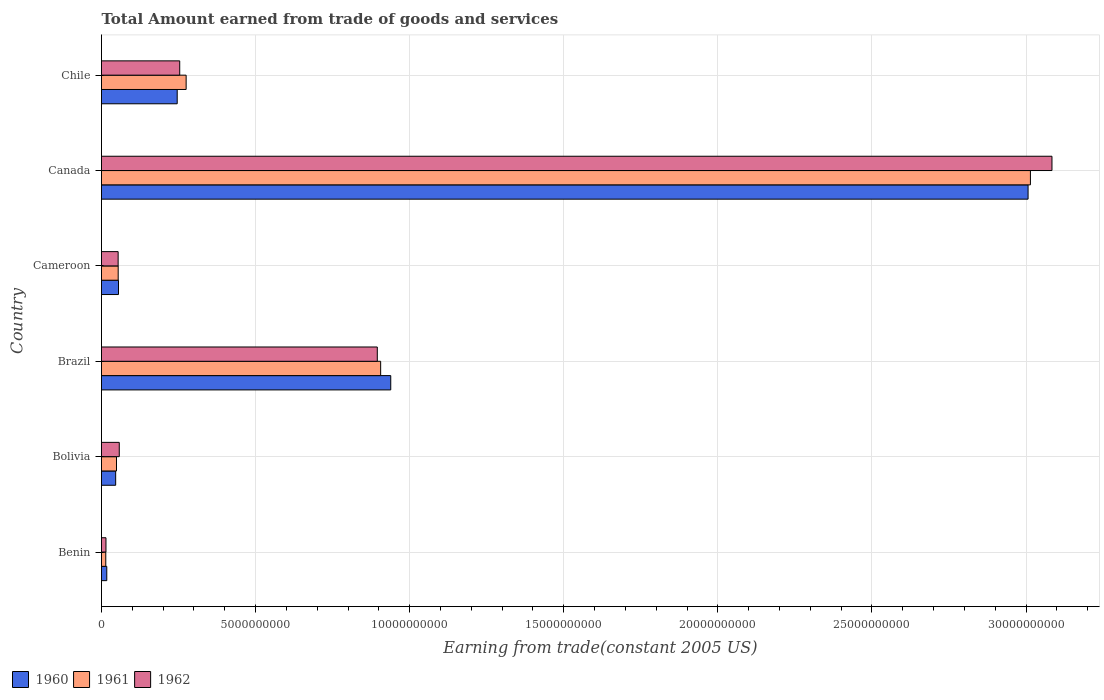How many different coloured bars are there?
Provide a short and direct response. 3. Are the number of bars per tick equal to the number of legend labels?
Your answer should be compact. Yes. How many bars are there on the 1st tick from the top?
Give a very brief answer. 3. How many bars are there on the 4th tick from the bottom?
Keep it short and to the point. 3. What is the label of the 2nd group of bars from the top?
Give a very brief answer. Canada. In how many cases, is the number of bars for a given country not equal to the number of legend labels?
Keep it short and to the point. 0. What is the total amount earned by trading goods and services in 1961 in Canada?
Provide a short and direct response. 3.01e+1. Across all countries, what is the maximum total amount earned by trading goods and services in 1962?
Provide a short and direct response. 3.08e+1. Across all countries, what is the minimum total amount earned by trading goods and services in 1960?
Make the answer very short. 1.71e+08. In which country was the total amount earned by trading goods and services in 1960 minimum?
Give a very brief answer. Benin. What is the total total amount earned by trading goods and services in 1962 in the graph?
Ensure brevity in your answer.  4.36e+1. What is the difference between the total amount earned by trading goods and services in 1960 in Cameroon and that in Canada?
Your answer should be compact. -2.95e+1. What is the difference between the total amount earned by trading goods and services in 1961 in Bolivia and the total amount earned by trading goods and services in 1962 in Brazil?
Give a very brief answer. -8.46e+09. What is the average total amount earned by trading goods and services in 1960 per country?
Your response must be concise. 7.18e+09. What is the difference between the total amount earned by trading goods and services in 1960 and total amount earned by trading goods and services in 1962 in Chile?
Keep it short and to the point. -8.15e+07. In how many countries, is the total amount earned by trading goods and services in 1961 greater than 4000000000 US$?
Provide a succinct answer. 2. What is the ratio of the total amount earned by trading goods and services in 1961 in Bolivia to that in Canada?
Your response must be concise. 0.02. What is the difference between the highest and the second highest total amount earned by trading goods and services in 1961?
Provide a short and direct response. 2.11e+1. What is the difference between the highest and the lowest total amount earned by trading goods and services in 1960?
Ensure brevity in your answer.  2.99e+1. What does the 2nd bar from the top in Benin represents?
Provide a succinct answer. 1961. What does the 3rd bar from the bottom in Chile represents?
Offer a very short reply. 1962. How many bars are there?
Ensure brevity in your answer.  18. Are all the bars in the graph horizontal?
Your answer should be compact. Yes. How many countries are there in the graph?
Your answer should be compact. 6. What is the difference between two consecutive major ticks on the X-axis?
Your answer should be very brief. 5.00e+09. Does the graph contain grids?
Provide a short and direct response. Yes. How are the legend labels stacked?
Make the answer very short. Horizontal. What is the title of the graph?
Offer a very short reply. Total Amount earned from trade of goods and services. Does "2014" appear as one of the legend labels in the graph?
Provide a succinct answer. No. What is the label or title of the X-axis?
Offer a terse response. Earning from trade(constant 2005 US). What is the label or title of the Y-axis?
Your answer should be compact. Country. What is the Earning from trade(constant 2005 US) in 1960 in Benin?
Provide a succinct answer. 1.71e+08. What is the Earning from trade(constant 2005 US) of 1961 in Benin?
Provide a short and direct response. 1.39e+08. What is the Earning from trade(constant 2005 US) in 1962 in Benin?
Offer a very short reply. 1.45e+08. What is the Earning from trade(constant 2005 US) in 1960 in Bolivia?
Ensure brevity in your answer.  4.60e+08. What is the Earning from trade(constant 2005 US) of 1961 in Bolivia?
Offer a very short reply. 4.87e+08. What is the Earning from trade(constant 2005 US) of 1962 in Bolivia?
Give a very brief answer. 5.76e+08. What is the Earning from trade(constant 2005 US) of 1960 in Brazil?
Give a very brief answer. 9.39e+09. What is the Earning from trade(constant 2005 US) of 1961 in Brazil?
Give a very brief answer. 9.06e+09. What is the Earning from trade(constant 2005 US) of 1962 in Brazil?
Offer a terse response. 8.95e+09. What is the Earning from trade(constant 2005 US) of 1960 in Cameroon?
Your answer should be compact. 5.52e+08. What is the Earning from trade(constant 2005 US) in 1961 in Cameroon?
Provide a short and direct response. 5.41e+08. What is the Earning from trade(constant 2005 US) of 1962 in Cameroon?
Your response must be concise. 5.40e+08. What is the Earning from trade(constant 2005 US) in 1960 in Canada?
Offer a terse response. 3.01e+1. What is the Earning from trade(constant 2005 US) in 1961 in Canada?
Your response must be concise. 3.01e+1. What is the Earning from trade(constant 2005 US) in 1962 in Canada?
Make the answer very short. 3.08e+1. What is the Earning from trade(constant 2005 US) of 1960 in Chile?
Your answer should be very brief. 2.46e+09. What is the Earning from trade(constant 2005 US) of 1961 in Chile?
Your answer should be very brief. 2.75e+09. What is the Earning from trade(constant 2005 US) of 1962 in Chile?
Make the answer very short. 2.54e+09. Across all countries, what is the maximum Earning from trade(constant 2005 US) of 1960?
Ensure brevity in your answer.  3.01e+1. Across all countries, what is the maximum Earning from trade(constant 2005 US) in 1961?
Your answer should be very brief. 3.01e+1. Across all countries, what is the maximum Earning from trade(constant 2005 US) of 1962?
Your answer should be very brief. 3.08e+1. Across all countries, what is the minimum Earning from trade(constant 2005 US) of 1960?
Offer a very short reply. 1.71e+08. Across all countries, what is the minimum Earning from trade(constant 2005 US) of 1961?
Your response must be concise. 1.39e+08. Across all countries, what is the minimum Earning from trade(constant 2005 US) of 1962?
Your response must be concise. 1.45e+08. What is the total Earning from trade(constant 2005 US) of 1960 in the graph?
Your answer should be very brief. 4.31e+1. What is the total Earning from trade(constant 2005 US) in 1961 in the graph?
Make the answer very short. 4.31e+1. What is the total Earning from trade(constant 2005 US) of 1962 in the graph?
Make the answer very short. 4.36e+1. What is the difference between the Earning from trade(constant 2005 US) of 1960 in Benin and that in Bolivia?
Your answer should be compact. -2.88e+08. What is the difference between the Earning from trade(constant 2005 US) in 1961 in Benin and that in Bolivia?
Your answer should be compact. -3.48e+08. What is the difference between the Earning from trade(constant 2005 US) of 1962 in Benin and that in Bolivia?
Your response must be concise. -4.31e+08. What is the difference between the Earning from trade(constant 2005 US) in 1960 in Benin and that in Brazil?
Your response must be concise. -9.21e+09. What is the difference between the Earning from trade(constant 2005 US) of 1961 in Benin and that in Brazil?
Your answer should be very brief. -8.92e+09. What is the difference between the Earning from trade(constant 2005 US) in 1962 in Benin and that in Brazil?
Your answer should be compact. -8.80e+09. What is the difference between the Earning from trade(constant 2005 US) in 1960 in Benin and that in Cameroon?
Your answer should be very brief. -3.80e+08. What is the difference between the Earning from trade(constant 2005 US) in 1961 in Benin and that in Cameroon?
Provide a short and direct response. -4.03e+08. What is the difference between the Earning from trade(constant 2005 US) of 1962 in Benin and that in Cameroon?
Provide a succinct answer. -3.95e+08. What is the difference between the Earning from trade(constant 2005 US) of 1960 in Benin and that in Canada?
Provide a succinct answer. -2.99e+1. What is the difference between the Earning from trade(constant 2005 US) in 1961 in Benin and that in Canada?
Provide a short and direct response. -3.00e+1. What is the difference between the Earning from trade(constant 2005 US) of 1962 in Benin and that in Canada?
Provide a succinct answer. -3.07e+1. What is the difference between the Earning from trade(constant 2005 US) of 1960 in Benin and that in Chile?
Your answer should be very brief. -2.29e+09. What is the difference between the Earning from trade(constant 2005 US) in 1961 in Benin and that in Chile?
Provide a short and direct response. -2.61e+09. What is the difference between the Earning from trade(constant 2005 US) in 1962 in Benin and that in Chile?
Your answer should be compact. -2.39e+09. What is the difference between the Earning from trade(constant 2005 US) of 1960 in Bolivia and that in Brazil?
Offer a terse response. -8.93e+09. What is the difference between the Earning from trade(constant 2005 US) of 1961 in Bolivia and that in Brazil?
Keep it short and to the point. -8.57e+09. What is the difference between the Earning from trade(constant 2005 US) of 1962 in Bolivia and that in Brazil?
Your answer should be very brief. -8.37e+09. What is the difference between the Earning from trade(constant 2005 US) of 1960 in Bolivia and that in Cameroon?
Offer a very short reply. -9.19e+07. What is the difference between the Earning from trade(constant 2005 US) of 1961 in Bolivia and that in Cameroon?
Make the answer very short. -5.46e+07. What is the difference between the Earning from trade(constant 2005 US) of 1962 in Bolivia and that in Cameroon?
Make the answer very short. 3.65e+07. What is the difference between the Earning from trade(constant 2005 US) of 1960 in Bolivia and that in Canada?
Your response must be concise. -2.96e+1. What is the difference between the Earning from trade(constant 2005 US) in 1961 in Bolivia and that in Canada?
Offer a terse response. -2.97e+1. What is the difference between the Earning from trade(constant 2005 US) of 1962 in Bolivia and that in Canada?
Provide a succinct answer. -3.03e+1. What is the difference between the Earning from trade(constant 2005 US) in 1960 in Bolivia and that in Chile?
Provide a short and direct response. -2.00e+09. What is the difference between the Earning from trade(constant 2005 US) in 1961 in Bolivia and that in Chile?
Ensure brevity in your answer.  -2.26e+09. What is the difference between the Earning from trade(constant 2005 US) of 1962 in Bolivia and that in Chile?
Offer a very short reply. -1.96e+09. What is the difference between the Earning from trade(constant 2005 US) of 1960 in Brazil and that in Cameroon?
Keep it short and to the point. 8.83e+09. What is the difference between the Earning from trade(constant 2005 US) of 1961 in Brazil and that in Cameroon?
Offer a terse response. 8.52e+09. What is the difference between the Earning from trade(constant 2005 US) in 1962 in Brazil and that in Cameroon?
Your answer should be very brief. 8.41e+09. What is the difference between the Earning from trade(constant 2005 US) in 1960 in Brazil and that in Canada?
Keep it short and to the point. -2.07e+1. What is the difference between the Earning from trade(constant 2005 US) in 1961 in Brazil and that in Canada?
Offer a terse response. -2.11e+1. What is the difference between the Earning from trade(constant 2005 US) of 1962 in Brazil and that in Canada?
Make the answer very short. -2.19e+1. What is the difference between the Earning from trade(constant 2005 US) in 1960 in Brazil and that in Chile?
Your answer should be very brief. 6.93e+09. What is the difference between the Earning from trade(constant 2005 US) of 1961 in Brazil and that in Chile?
Ensure brevity in your answer.  6.31e+09. What is the difference between the Earning from trade(constant 2005 US) in 1962 in Brazil and that in Chile?
Offer a terse response. 6.41e+09. What is the difference between the Earning from trade(constant 2005 US) of 1960 in Cameroon and that in Canada?
Your answer should be compact. -2.95e+1. What is the difference between the Earning from trade(constant 2005 US) of 1961 in Cameroon and that in Canada?
Offer a very short reply. -2.96e+1. What is the difference between the Earning from trade(constant 2005 US) of 1962 in Cameroon and that in Canada?
Offer a very short reply. -3.03e+1. What is the difference between the Earning from trade(constant 2005 US) in 1960 in Cameroon and that in Chile?
Your answer should be very brief. -1.90e+09. What is the difference between the Earning from trade(constant 2005 US) in 1961 in Cameroon and that in Chile?
Keep it short and to the point. -2.21e+09. What is the difference between the Earning from trade(constant 2005 US) in 1962 in Cameroon and that in Chile?
Make the answer very short. -2.00e+09. What is the difference between the Earning from trade(constant 2005 US) in 1960 in Canada and that in Chile?
Give a very brief answer. 2.76e+1. What is the difference between the Earning from trade(constant 2005 US) in 1961 in Canada and that in Chile?
Ensure brevity in your answer.  2.74e+1. What is the difference between the Earning from trade(constant 2005 US) of 1962 in Canada and that in Chile?
Give a very brief answer. 2.83e+1. What is the difference between the Earning from trade(constant 2005 US) of 1960 in Benin and the Earning from trade(constant 2005 US) of 1961 in Bolivia?
Offer a very short reply. -3.15e+08. What is the difference between the Earning from trade(constant 2005 US) of 1960 in Benin and the Earning from trade(constant 2005 US) of 1962 in Bolivia?
Provide a short and direct response. -4.05e+08. What is the difference between the Earning from trade(constant 2005 US) in 1961 in Benin and the Earning from trade(constant 2005 US) in 1962 in Bolivia?
Ensure brevity in your answer.  -4.38e+08. What is the difference between the Earning from trade(constant 2005 US) in 1960 in Benin and the Earning from trade(constant 2005 US) in 1961 in Brazil?
Your answer should be very brief. -8.89e+09. What is the difference between the Earning from trade(constant 2005 US) in 1960 in Benin and the Earning from trade(constant 2005 US) in 1962 in Brazil?
Your answer should be compact. -8.78e+09. What is the difference between the Earning from trade(constant 2005 US) of 1961 in Benin and the Earning from trade(constant 2005 US) of 1962 in Brazil?
Give a very brief answer. -8.81e+09. What is the difference between the Earning from trade(constant 2005 US) of 1960 in Benin and the Earning from trade(constant 2005 US) of 1961 in Cameroon?
Give a very brief answer. -3.70e+08. What is the difference between the Earning from trade(constant 2005 US) in 1960 in Benin and the Earning from trade(constant 2005 US) in 1962 in Cameroon?
Your response must be concise. -3.69e+08. What is the difference between the Earning from trade(constant 2005 US) of 1961 in Benin and the Earning from trade(constant 2005 US) of 1962 in Cameroon?
Ensure brevity in your answer.  -4.01e+08. What is the difference between the Earning from trade(constant 2005 US) of 1960 in Benin and the Earning from trade(constant 2005 US) of 1961 in Canada?
Your answer should be compact. -3.00e+1. What is the difference between the Earning from trade(constant 2005 US) of 1960 in Benin and the Earning from trade(constant 2005 US) of 1962 in Canada?
Your answer should be compact. -3.07e+1. What is the difference between the Earning from trade(constant 2005 US) in 1961 in Benin and the Earning from trade(constant 2005 US) in 1962 in Canada?
Ensure brevity in your answer.  -3.07e+1. What is the difference between the Earning from trade(constant 2005 US) in 1960 in Benin and the Earning from trade(constant 2005 US) in 1961 in Chile?
Your response must be concise. -2.58e+09. What is the difference between the Earning from trade(constant 2005 US) in 1960 in Benin and the Earning from trade(constant 2005 US) in 1962 in Chile?
Keep it short and to the point. -2.37e+09. What is the difference between the Earning from trade(constant 2005 US) in 1961 in Benin and the Earning from trade(constant 2005 US) in 1962 in Chile?
Offer a terse response. -2.40e+09. What is the difference between the Earning from trade(constant 2005 US) in 1960 in Bolivia and the Earning from trade(constant 2005 US) in 1961 in Brazil?
Offer a terse response. -8.60e+09. What is the difference between the Earning from trade(constant 2005 US) of 1960 in Bolivia and the Earning from trade(constant 2005 US) of 1962 in Brazil?
Your answer should be compact. -8.49e+09. What is the difference between the Earning from trade(constant 2005 US) in 1961 in Bolivia and the Earning from trade(constant 2005 US) in 1962 in Brazil?
Give a very brief answer. -8.46e+09. What is the difference between the Earning from trade(constant 2005 US) in 1960 in Bolivia and the Earning from trade(constant 2005 US) in 1961 in Cameroon?
Provide a short and direct response. -8.15e+07. What is the difference between the Earning from trade(constant 2005 US) of 1960 in Bolivia and the Earning from trade(constant 2005 US) of 1962 in Cameroon?
Keep it short and to the point. -8.02e+07. What is the difference between the Earning from trade(constant 2005 US) of 1961 in Bolivia and the Earning from trade(constant 2005 US) of 1962 in Cameroon?
Keep it short and to the point. -5.33e+07. What is the difference between the Earning from trade(constant 2005 US) in 1960 in Bolivia and the Earning from trade(constant 2005 US) in 1961 in Canada?
Provide a short and direct response. -2.97e+1. What is the difference between the Earning from trade(constant 2005 US) in 1960 in Bolivia and the Earning from trade(constant 2005 US) in 1962 in Canada?
Offer a terse response. -3.04e+1. What is the difference between the Earning from trade(constant 2005 US) in 1961 in Bolivia and the Earning from trade(constant 2005 US) in 1962 in Canada?
Ensure brevity in your answer.  -3.04e+1. What is the difference between the Earning from trade(constant 2005 US) in 1960 in Bolivia and the Earning from trade(constant 2005 US) in 1961 in Chile?
Your answer should be compact. -2.29e+09. What is the difference between the Earning from trade(constant 2005 US) of 1960 in Bolivia and the Earning from trade(constant 2005 US) of 1962 in Chile?
Your answer should be very brief. -2.08e+09. What is the difference between the Earning from trade(constant 2005 US) of 1961 in Bolivia and the Earning from trade(constant 2005 US) of 1962 in Chile?
Your response must be concise. -2.05e+09. What is the difference between the Earning from trade(constant 2005 US) in 1960 in Brazil and the Earning from trade(constant 2005 US) in 1961 in Cameroon?
Offer a terse response. 8.84e+09. What is the difference between the Earning from trade(constant 2005 US) of 1960 in Brazil and the Earning from trade(constant 2005 US) of 1962 in Cameroon?
Offer a terse response. 8.85e+09. What is the difference between the Earning from trade(constant 2005 US) in 1961 in Brazil and the Earning from trade(constant 2005 US) in 1962 in Cameroon?
Offer a terse response. 8.52e+09. What is the difference between the Earning from trade(constant 2005 US) of 1960 in Brazil and the Earning from trade(constant 2005 US) of 1961 in Canada?
Your answer should be compact. -2.08e+1. What is the difference between the Earning from trade(constant 2005 US) of 1960 in Brazil and the Earning from trade(constant 2005 US) of 1962 in Canada?
Your response must be concise. -2.15e+1. What is the difference between the Earning from trade(constant 2005 US) of 1961 in Brazil and the Earning from trade(constant 2005 US) of 1962 in Canada?
Provide a succinct answer. -2.18e+1. What is the difference between the Earning from trade(constant 2005 US) in 1960 in Brazil and the Earning from trade(constant 2005 US) in 1961 in Chile?
Make the answer very short. 6.64e+09. What is the difference between the Earning from trade(constant 2005 US) in 1960 in Brazil and the Earning from trade(constant 2005 US) in 1962 in Chile?
Your response must be concise. 6.85e+09. What is the difference between the Earning from trade(constant 2005 US) of 1961 in Brazil and the Earning from trade(constant 2005 US) of 1962 in Chile?
Offer a terse response. 6.52e+09. What is the difference between the Earning from trade(constant 2005 US) of 1960 in Cameroon and the Earning from trade(constant 2005 US) of 1961 in Canada?
Provide a succinct answer. -2.96e+1. What is the difference between the Earning from trade(constant 2005 US) of 1960 in Cameroon and the Earning from trade(constant 2005 US) of 1962 in Canada?
Your response must be concise. -3.03e+1. What is the difference between the Earning from trade(constant 2005 US) in 1961 in Cameroon and the Earning from trade(constant 2005 US) in 1962 in Canada?
Keep it short and to the point. -3.03e+1. What is the difference between the Earning from trade(constant 2005 US) in 1960 in Cameroon and the Earning from trade(constant 2005 US) in 1961 in Chile?
Provide a short and direct response. -2.19e+09. What is the difference between the Earning from trade(constant 2005 US) in 1960 in Cameroon and the Earning from trade(constant 2005 US) in 1962 in Chile?
Your answer should be very brief. -1.99e+09. What is the difference between the Earning from trade(constant 2005 US) of 1961 in Cameroon and the Earning from trade(constant 2005 US) of 1962 in Chile?
Offer a very short reply. -2.00e+09. What is the difference between the Earning from trade(constant 2005 US) of 1960 in Canada and the Earning from trade(constant 2005 US) of 1961 in Chile?
Keep it short and to the point. 2.73e+1. What is the difference between the Earning from trade(constant 2005 US) in 1960 in Canada and the Earning from trade(constant 2005 US) in 1962 in Chile?
Make the answer very short. 2.75e+1. What is the difference between the Earning from trade(constant 2005 US) of 1961 in Canada and the Earning from trade(constant 2005 US) of 1962 in Chile?
Give a very brief answer. 2.76e+1. What is the average Earning from trade(constant 2005 US) of 1960 per country?
Provide a succinct answer. 7.18e+09. What is the average Earning from trade(constant 2005 US) of 1961 per country?
Ensure brevity in your answer.  7.19e+09. What is the average Earning from trade(constant 2005 US) of 1962 per country?
Give a very brief answer. 7.26e+09. What is the difference between the Earning from trade(constant 2005 US) of 1960 and Earning from trade(constant 2005 US) of 1961 in Benin?
Offer a terse response. 3.26e+07. What is the difference between the Earning from trade(constant 2005 US) in 1960 and Earning from trade(constant 2005 US) in 1962 in Benin?
Offer a very short reply. 2.63e+07. What is the difference between the Earning from trade(constant 2005 US) of 1961 and Earning from trade(constant 2005 US) of 1962 in Benin?
Make the answer very short. -6.31e+06. What is the difference between the Earning from trade(constant 2005 US) in 1960 and Earning from trade(constant 2005 US) in 1961 in Bolivia?
Ensure brevity in your answer.  -2.69e+07. What is the difference between the Earning from trade(constant 2005 US) of 1960 and Earning from trade(constant 2005 US) of 1962 in Bolivia?
Ensure brevity in your answer.  -1.17e+08. What is the difference between the Earning from trade(constant 2005 US) in 1961 and Earning from trade(constant 2005 US) in 1962 in Bolivia?
Offer a terse response. -8.97e+07. What is the difference between the Earning from trade(constant 2005 US) in 1960 and Earning from trade(constant 2005 US) in 1961 in Brazil?
Ensure brevity in your answer.  3.27e+08. What is the difference between the Earning from trade(constant 2005 US) of 1960 and Earning from trade(constant 2005 US) of 1962 in Brazil?
Ensure brevity in your answer.  4.36e+08. What is the difference between the Earning from trade(constant 2005 US) of 1961 and Earning from trade(constant 2005 US) of 1962 in Brazil?
Your response must be concise. 1.09e+08. What is the difference between the Earning from trade(constant 2005 US) in 1960 and Earning from trade(constant 2005 US) in 1961 in Cameroon?
Your answer should be compact. 1.04e+07. What is the difference between the Earning from trade(constant 2005 US) of 1960 and Earning from trade(constant 2005 US) of 1962 in Cameroon?
Give a very brief answer. 1.17e+07. What is the difference between the Earning from trade(constant 2005 US) of 1961 and Earning from trade(constant 2005 US) of 1962 in Cameroon?
Provide a short and direct response. 1.36e+06. What is the difference between the Earning from trade(constant 2005 US) in 1960 and Earning from trade(constant 2005 US) in 1961 in Canada?
Make the answer very short. -7.60e+07. What is the difference between the Earning from trade(constant 2005 US) of 1960 and Earning from trade(constant 2005 US) of 1962 in Canada?
Offer a terse response. -7.75e+08. What is the difference between the Earning from trade(constant 2005 US) of 1961 and Earning from trade(constant 2005 US) of 1962 in Canada?
Offer a very short reply. -6.99e+08. What is the difference between the Earning from trade(constant 2005 US) of 1960 and Earning from trade(constant 2005 US) of 1961 in Chile?
Provide a short and direct response. -2.90e+08. What is the difference between the Earning from trade(constant 2005 US) of 1960 and Earning from trade(constant 2005 US) of 1962 in Chile?
Your answer should be compact. -8.15e+07. What is the difference between the Earning from trade(constant 2005 US) in 1961 and Earning from trade(constant 2005 US) in 1962 in Chile?
Provide a succinct answer. 2.09e+08. What is the ratio of the Earning from trade(constant 2005 US) in 1960 in Benin to that in Bolivia?
Ensure brevity in your answer.  0.37. What is the ratio of the Earning from trade(constant 2005 US) of 1961 in Benin to that in Bolivia?
Offer a terse response. 0.29. What is the ratio of the Earning from trade(constant 2005 US) of 1962 in Benin to that in Bolivia?
Offer a very short reply. 0.25. What is the ratio of the Earning from trade(constant 2005 US) of 1960 in Benin to that in Brazil?
Your answer should be very brief. 0.02. What is the ratio of the Earning from trade(constant 2005 US) in 1961 in Benin to that in Brazil?
Keep it short and to the point. 0.02. What is the ratio of the Earning from trade(constant 2005 US) of 1962 in Benin to that in Brazil?
Give a very brief answer. 0.02. What is the ratio of the Earning from trade(constant 2005 US) of 1960 in Benin to that in Cameroon?
Give a very brief answer. 0.31. What is the ratio of the Earning from trade(constant 2005 US) in 1961 in Benin to that in Cameroon?
Keep it short and to the point. 0.26. What is the ratio of the Earning from trade(constant 2005 US) of 1962 in Benin to that in Cameroon?
Your answer should be very brief. 0.27. What is the ratio of the Earning from trade(constant 2005 US) in 1960 in Benin to that in Canada?
Offer a very short reply. 0.01. What is the ratio of the Earning from trade(constant 2005 US) of 1961 in Benin to that in Canada?
Provide a succinct answer. 0. What is the ratio of the Earning from trade(constant 2005 US) of 1962 in Benin to that in Canada?
Provide a succinct answer. 0. What is the ratio of the Earning from trade(constant 2005 US) in 1960 in Benin to that in Chile?
Give a very brief answer. 0.07. What is the ratio of the Earning from trade(constant 2005 US) in 1961 in Benin to that in Chile?
Ensure brevity in your answer.  0.05. What is the ratio of the Earning from trade(constant 2005 US) in 1962 in Benin to that in Chile?
Provide a short and direct response. 0.06. What is the ratio of the Earning from trade(constant 2005 US) of 1960 in Bolivia to that in Brazil?
Your answer should be very brief. 0.05. What is the ratio of the Earning from trade(constant 2005 US) in 1961 in Bolivia to that in Brazil?
Your answer should be compact. 0.05. What is the ratio of the Earning from trade(constant 2005 US) in 1962 in Bolivia to that in Brazil?
Ensure brevity in your answer.  0.06. What is the ratio of the Earning from trade(constant 2005 US) in 1960 in Bolivia to that in Cameroon?
Your answer should be very brief. 0.83. What is the ratio of the Earning from trade(constant 2005 US) of 1961 in Bolivia to that in Cameroon?
Provide a short and direct response. 0.9. What is the ratio of the Earning from trade(constant 2005 US) in 1962 in Bolivia to that in Cameroon?
Your answer should be compact. 1.07. What is the ratio of the Earning from trade(constant 2005 US) in 1960 in Bolivia to that in Canada?
Your answer should be very brief. 0.02. What is the ratio of the Earning from trade(constant 2005 US) in 1961 in Bolivia to that in Canada?
Give a very brief answer. 0.02. What is the ratio of the Earning from trade(constant 2005 US) in 1962 in Bolivia to that in Canada?
Offer a very short reply. 0.02. What is the ratio of the Earning from trade(constant 2005 US) of 1960 in Bolivia to that in Chile?
Ensure brevity in your answer.  0.19. What is the ratio of the Earning from trade(constant 2005 US) in 1961 in Bolivia to that in Chile?
Provide a succinct answer. 0.18. What is the ratio of the Earning from trade(constant 2005 US) of 1962 in Bolivia to that in Chile?
Provide a short and direct response. 0.23. What is the ratio of the Earning from trade(constant 2005 US) of 1960 in Brazil to that in Cameroon?
Keep it short and to the point. 17.01. What is the ratio of the Earning from trade(constant 2005 US) of 1961 in Brazil to that in Cameroon?
Offer a terse response. 16.73. What is the ratio of the Earning from trade(constant 2005 US) of 1962 in Brazil to that in Cameroon?
Your answer should be compact. 16.57. What is the ratio of the Earning from trade(constant 2005 US) of 1960 in Brazil to that in Canada?
Keep it short and to the point. 0.31. What is the ratio of the Earning from trade(constant 2005 US) in 1961 in Brazil to that in Canada?
Your answer should be compact. 0.3. What is the ratio of the Earning from trade(constant 2005 US) in 1962 in Brazil to that in Canada?
Your response must be concise. 0.29. What is the ratio of the Earning from trade(constant 2005 US) in 1960 in Brazil to that in Chile?
Provide a succinct answer. 3.82. What is the ratio of the Earning from trade(constant 2005 US) of 1961 in Brazil to that in Chile?
Give a very brief answer. 3.3. What is the ratio of the Earning from trade(constant 2005 US) in 1962 in Brazil to that in Chile?
Your response must be concise. 3.53. What is the ratio of the Earning from trade(constant 2005 US) in 1960 in Cameroon to that in Canada?
Provide a short and direct response. 0.02. What is the ratio of the Earning from trade(constant 2005 US) in 1961 in Cameroon to that in Canada?
Provide a short and direct response. 0.02. What is the ratio of the Earning from trade(constant 2005 US) in 1962 in Cameroon to that in Canada?
Your response must be concise. 0.02. What is the ratio of the Earning from trade(constant 2005 US) of 1960 in Cameroon to that in Chile?
Your answer should be compact. 0.22. What is the ratio of the Earning from trade(constant 2005 US) in 1961 in Cameroon to that in Chile?
Your answer should be very brief. 0.2. What is the ratio of the Earning from trade(constant 2005 US) in 1962 in Cameroon to that in Chile?
Provide a succinct answer. 0.21. What is the ratio of the Earning from trade(constant 2005 US) in 1960 in Canada to that in Chile?
Give a very brief answer. 12.24. What is the ratio of the Earning from trade(constant 2005 US) in 1961 in Canada to that in Chile?
Provide a short and direct response. 10.97. What is the ratio of the Earning from trade(constant 2005 US) of 1962 in Canada to that in Chile?
Your answer should be compact. 12.15. What is the difference between the highest and the second highest Earning from trade(constant 2005 US) of 1960?
Give a very brief answer. 2.07e+1. What is the difference between the highest and the second highest Earning from trade(constant 2005 US) of 1961?
Provide a short and direct response. 2.11e+1. What is the difference between the highest and the second highest Earning from trade(constant 2005 US) in 1962?
Provide a succinct answer. 2.19e+1. What is the difference between the highest and the lowest Earning from trade(constant 2005 US) in 1960?
Provide a short and direct response. 2.99e+1. What is the difference between the highest and the lowest Earning from trade(constant 2005 US) in 1961?
Your answer should be very brief. 3.00e+1. What is the difference between the highest and the lowest Earning from trade(constant 2005 US) in 1962?
Your answer should be very brief. 3.07e+1. 